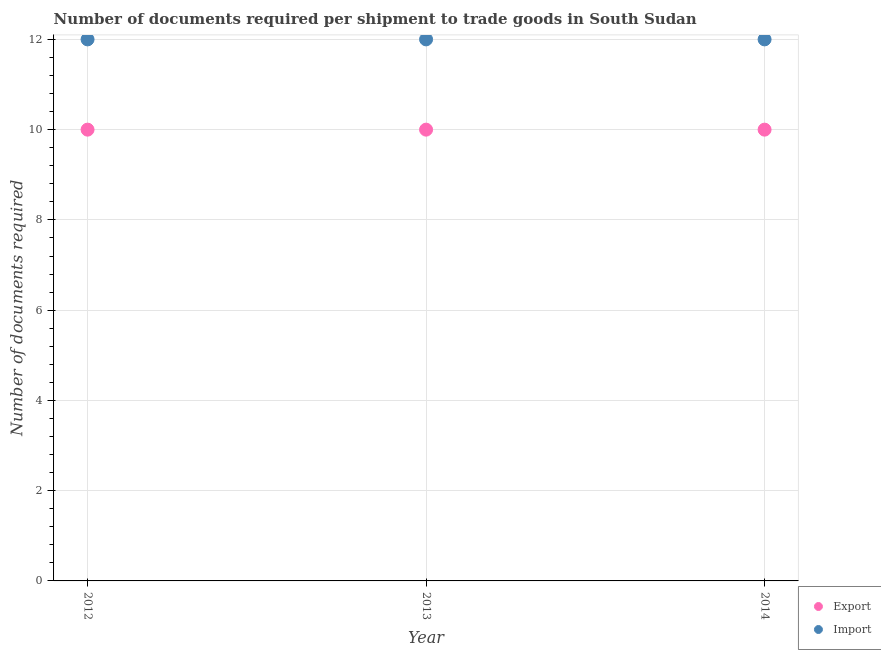What is the number of documents required to export goods in 2013?
Ensure brevity in your answer.  10. Across all years, what is the maximum number of documents required to import goods?
Provide a succinct answer. 12. Across all years, what is the minimum number of documents required to export goods?
Provide a short and direct response. 10. What is the total number of documents required to import goods in the graph?
Offer a terse response. 36. What is the difference between the number of documents required to export goods in 2013 and that in 2014?
Keep it short and to the point. 0. What is the difference between the number of documents required to import goods in 2014 and the number of documents required to export goods in 2012?
Make the answer very short. 2. In the year 2013, what is the difference between the number of documents required to import goods and number of documents required to export goods?
Provide a short and direct response. 2. In how many years, is the number of documents required to import goods greater than 1.6?
Provide a short and direct response. 3. Is the difference between the number of documents required to export goods in 2013 and 2014 greater than the difference between the number of documents required to import goods in 2013 and 2014?
Ensure brevity in your answer.  No. What is the difference between the highest and the lowest number of documents required to export goods?
Keep it short and to the point. 0. In how many years, is the number of documents required to import goods greater than the average number of documents required to import goods taken over all years?
Ensure brevity in your answer.  0. Is the sum of the number of documents required to import goods in 2012 and 2013 greater than the maximum number of documents required to export goods across all years?
Make the answer very short. Yes. What is the difference between two consecutive major ticks on the Y-axis?
Your response must be concise. 2. Where does the legend appear in the graph?
Provide a succinct answer. Bottom right. How many legend labels are there?
Offer a very short reply. 2. How are the legend labels stacked?
Offer a terse response. Vertical. What is the title of the graph?
Offer a terse response. Number of documents required per shipment to trade goods in South Sudan. Does "From production" appear as one of the legend labels in the graph?
Offer a very short reply. No. What is the label or title of the X-axis?
Ensure brevity in your answer.  Year. What is the label or title of the Y-axis?
Make the answer very short. Number of documents required. What is the Number of documents required of Export in 2012?
Your answer should be compact. 10. What is the Number of documents required in Import in 2012?
Provide a short and direct response. 12. What is the Number of documents required of Export in 2014?
Make the answer very short. 10. What is the total Number of documents required of Export in the graph?
Keep it short and to the point. 30. What is the total Number of documents required in Import in the graph?
Make the answer very short. 36. What is the difference between the Number of documents required of Export in 2012 and that in 2013?
Provide a succinct answer. 0. What is the difference between the Number of documents required in Import in 2012 and that in 2014?
Provide a short and direct response. 0. What is the difference between the Number of documents required in Import in 2013 and that in 2014?
Provide a short and direct response. 0. What is the difference between the Number of documents required in Export in 2012 and the Number of documents required in Import in 2013?
Offer a very short reply. -2. What is the difference between the Number of documents required in Export in 2012 and the Number of documents required in Import in 2014?
Keep it short and to the point. -2. What is the average Number of documents required of Export per year?
Provide a short and direct response. 10. What is the average Number of documents required of Import per year?
Offer a terse response. 12. In the year 2014, what is the difference between the Number of documents required in Export and Number of documents required in Import?
Your response must be concise. -2. What is the ratio of the Number of documents required of Import in 2012 to that in 2013?
Ensure brevity in your answer.  1. What is the difference between the highest and the second highest Number of documents required of Export?
Keep it short and to the point. 0. 